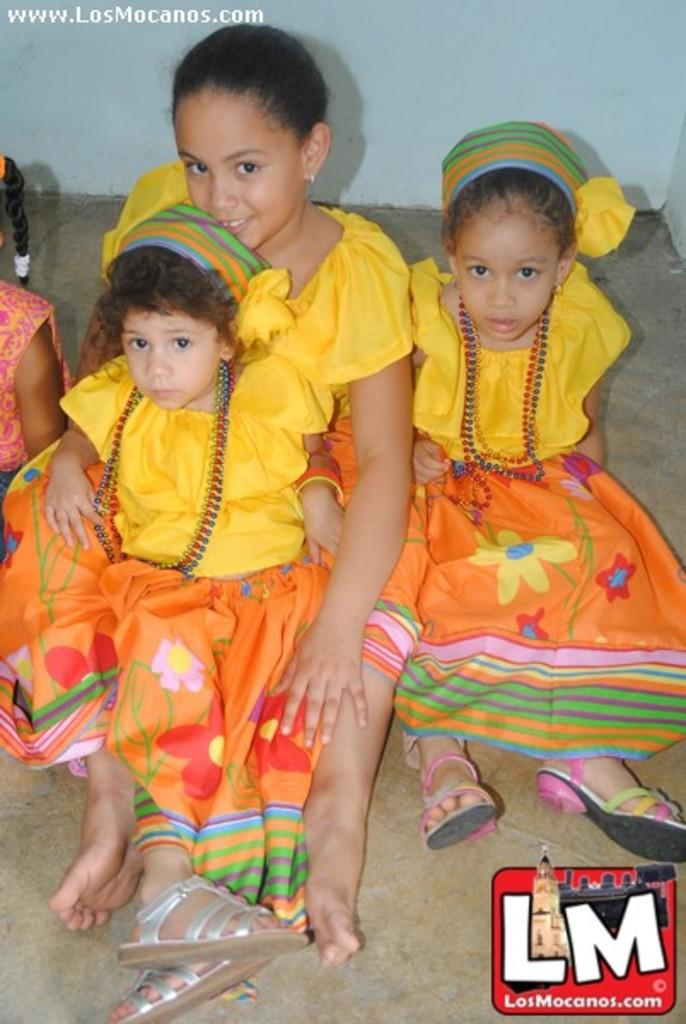How many girls are in the image? There are three girls in the image. What are the girls wearing? The girls are wearing yellow dresses and an orange frock. What are the girls doing in the image? The girls are sitting on the floor. What can be seen in the background of the image? There is a wall visible in the background. Are there any other people in the image besides the three girls? Yes, there is another girl visible on the left side of the image. What type of icicle can be seen hanging from the girl's hair in the image? There is no icicle present in the image; the girls are wearing dresses and sitting on the floor. What journey are the girls embarking on in the image? There is no indication of a journey in the image; the girls are simply sitting on the floor. 